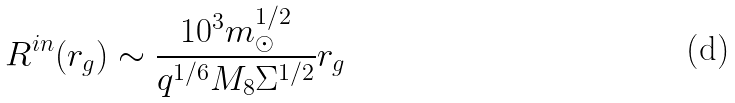<formula> <loc_0><loc_0><loc_500><loc_500>R ^ { i n } ( r _ { g } ) \sim \frac { 1 0 ^ { 3 } m _ { \odot } ^ { 1 / 2 } } { q ^ { 1 / 6 } M _ { 8 } \Sigma ^ { 1 / 2 } } r _ { g }</formula> 